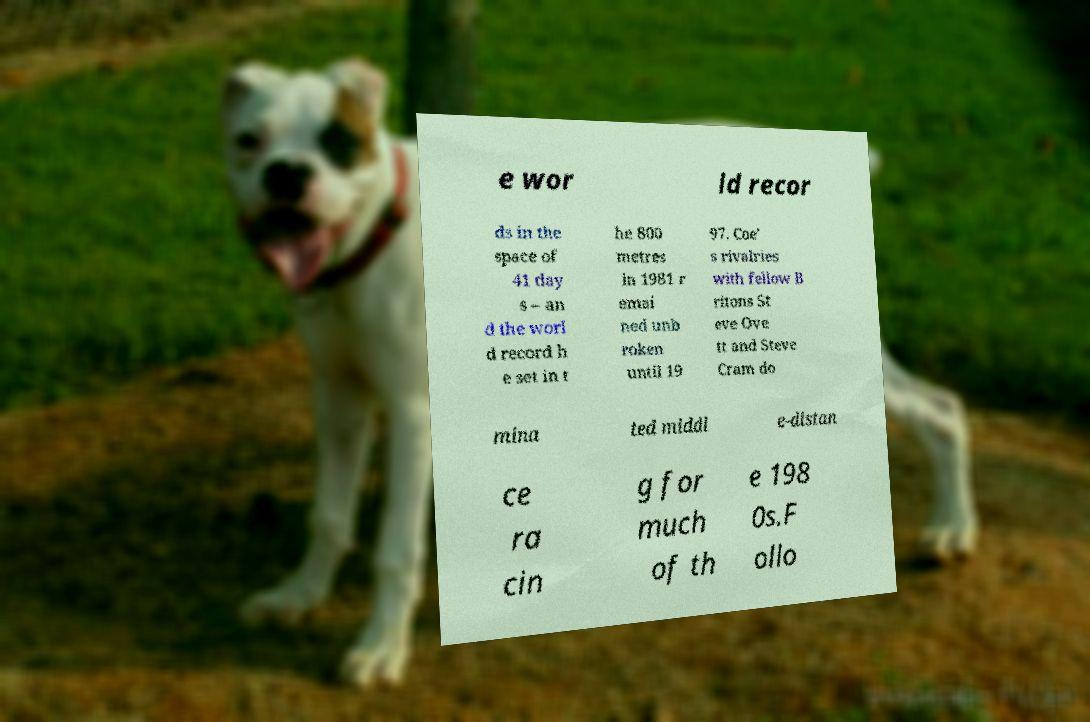Please read and relay the text visible in this image. What does it say? e wor ld recor ds in the space of 41 day s – an d the worl d record h e set in t he 800 metres in 1981 r emai ned unb roken until 19 97. Coe' s rivalries with fellow B ritons St eve Ove tt and Steve Cram do mina ted middl e-distan ce ra cin g for much of th e 198 0s.F ollo 